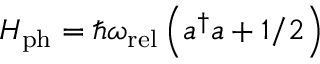<formula> <loc_0><loc_0><loc_500><loc_500>H _ { p h } = \hbar { \omega } _ { r e l } \left ( a ^ { \dagger } a + 1 / 2 \right )</formula> 